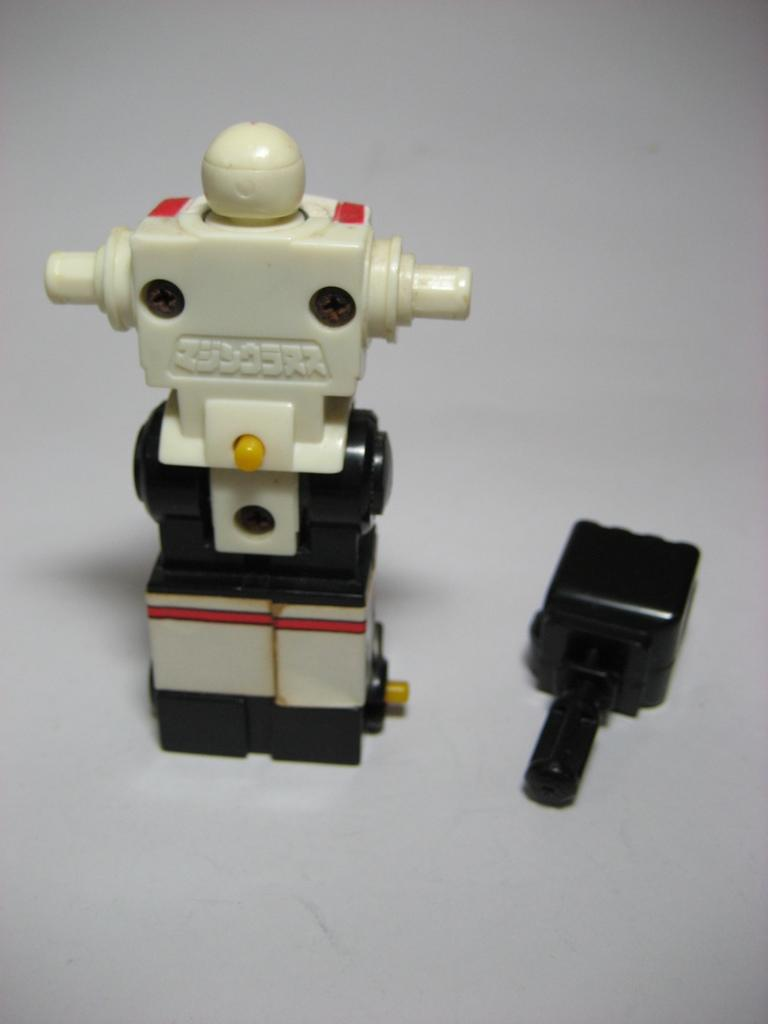What type of object is in the image? There is a toy in the image. What is the toy shaped like? The toy is in the shape of a robot. What colors can be seen on the toy? The toy has a white and black color scheme. What type of sponge is used for cleaning the robot toy in the image? There is no sponge present in the image, nor is there any indication that the robot toy needs cleaning. 